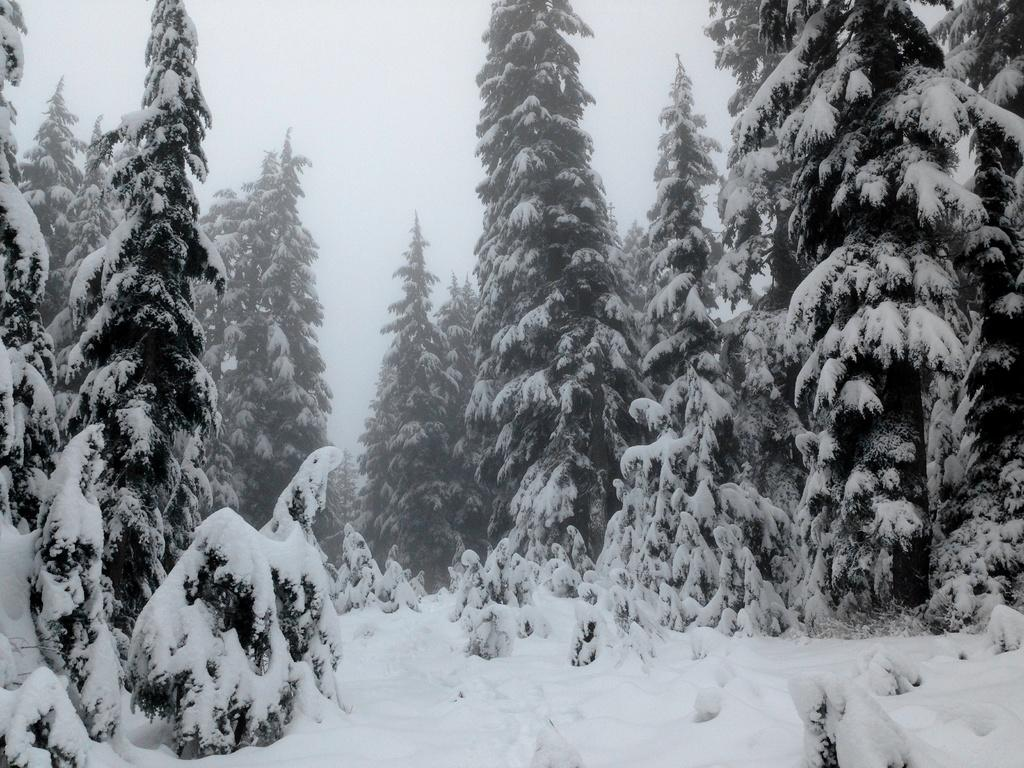What type of trees can be seen in the image? There are tall trees in the image. How are the trees affected by the weather? The trees are filled with snow. What is the overall condition of the area in the image? The entire area is covered with dense ice. What type of screw can be seen holding the cabbage to the brick wall in the image? There is no screw, cabbage, or brick wall present in the image; it features tall trees filled with snow and covered with dense ice. 